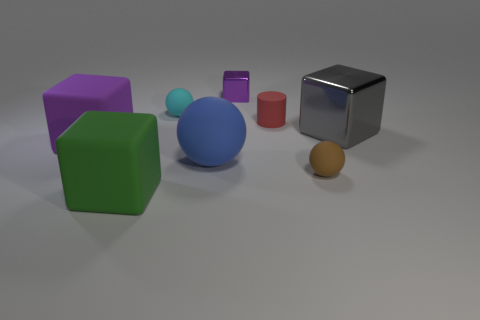Are there the same number of brown rubber balls on the left side of the large green matte block and brown things behind the blue rubber ball?
Your answer should be compact. Yes. Does the purple object that is in front of the gray thing have the same material as the small purple cube?
Your response must be concise. No. What is the color of the matte ball that is left of the red object and in front of the cyan rubber sphere?
Offer a very short reply. Blue. What number of blocks are behind the large green matte block that is left of the blue thing?
Provide a short and direct response. 3. There is a large green thing that is the same shape as the small metallic object; what material is it?
Provide a succinct answer. Rubber. The tiny cylinder is what color?
Offer a terse response. Red. What number of things are large spheres or big purple blocks?
Your answer should be very brief. 2. The small rubber object in front of the purple block that is in front of the small red matte thing is what shape?
Keep it short and to the point. Sphere. How many other things are the same material as the large purple cube?
Provide a short and direct response. 5. Is the material of the tiny cyan sphere the same as the big thing to the right of the big blue thing?
Your answer should be compact. No. 